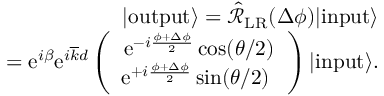Convert formula to latex. <formula><loc_0><loc_0><loc_500><loc_500>\begin{array} { r l r } & { | o u t p u t \rangle = \hat { \mathcal { R } } _ { L R } ( \Delta \phi ) | i n p u t \rangle } \\ & { = e ^ { i \beta } e ^ { i \overline { k } d } \left ( \begin{array} { c } { e ^ { - i \frac { \phi + \Delta \phi } { 2 } } \cos ( \theta / 2 ) } \\ { e ^ { + i \frac { \phi + \Delta \phi } { 2 } } \sin ( \theta / 2 ) \ } \end{array} \right ) | i n p u t \rangle . } \end{array}</formula> 